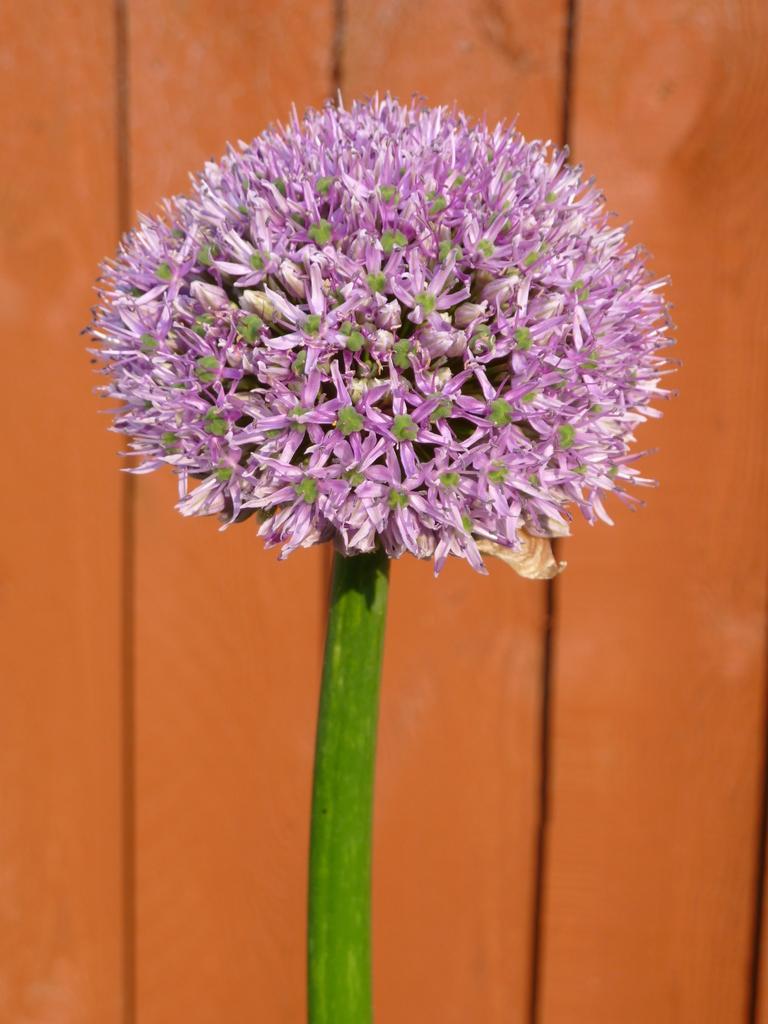Can you describe this image briefly? In the image in the center, we can see one flower, which is in pink color. In the background there is a wooden wall. 